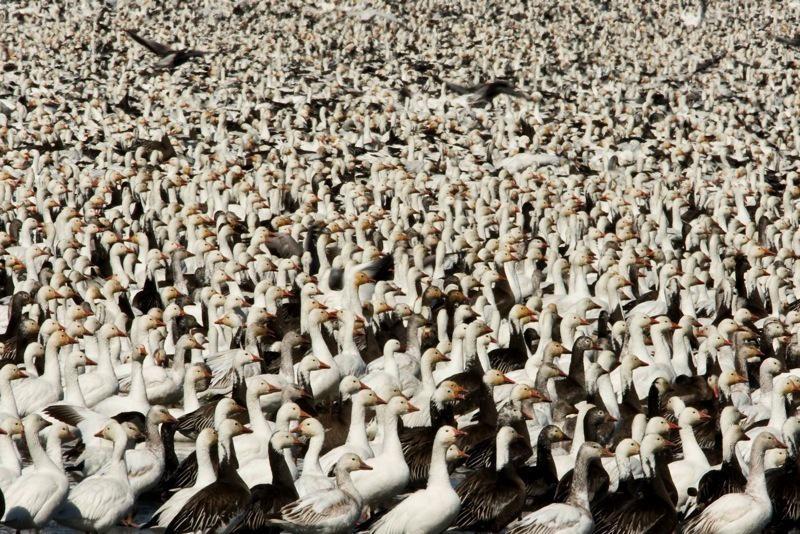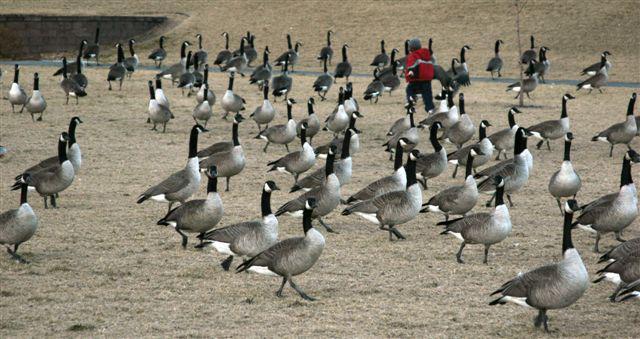The first image is the image on the left, the second image is the image on the right. Considering the images on both sides, is "Someone is in the field with the animals." valid? Answer yes or no. Yes. The first image is the image on the left, the second image is the image on the right. For the images shown, is this caption "The birds in the image on the right are primarily white." true? Answer yes or no. No. 